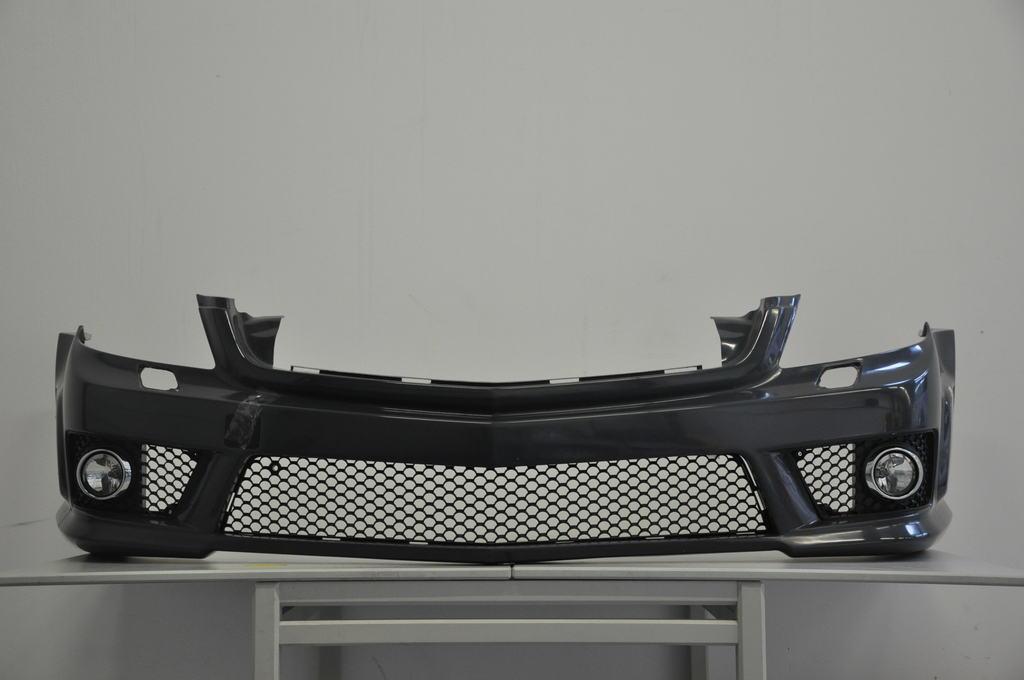How would you summarize this image in a sentence or two? In this image there is a table towards the bottom of the image, there is a grille on the table, at the background of the image there is a wall. 